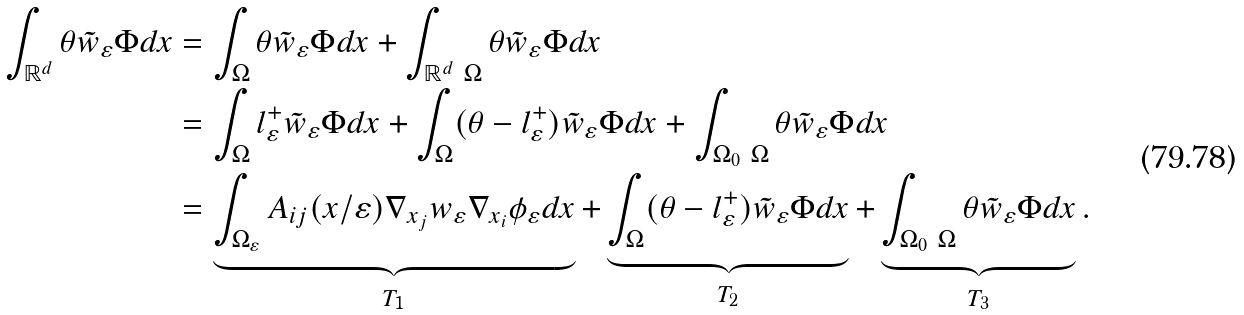Convert formula to latex. <formula><loc_0><loc_0><loc_500><loc_500>\int _ { \mathbb { R } ^ { d } } \theta \tilde { w } _ { \varepsilon } \Phi d x & = \int _ { \Omega } \theta \tilde { w } _ { \varepsilon } \Phi d x + \int _ { \mathbb { R } ^ { d } \ \Omega } \theta \tilde { w } _ { \varepsilon } \Phi d x \\ & = \int _ { \Omega } l _ { \varepsilon } ^ { + } \tilde { w } _ { \varepsilon } \Phi d x + \int _ { \Omega } ( \theta - l _ { \varepsilon } ^ { + } ) \tilde { w } _ { \varepsilon } \Phi d x + \int _ { \Omega _ { 0 } \ \Omega } \theta \tilde { w } _ { \varepsilon } \Phi d x \\ & = \underbrace { \int _ { \Omega _ { \varepsilon } } A _ { i j } ( x / \varepsilon ) \nabla _ { x _ { j } } w _ { \varepsilon } \nabla _ { x _ { i } } \phi _ { \varepsilon } d x } _ { T _ { 1 } } + \underbrace { \int _ { \Omega } ( \theta - l _ { \varepsilon } ^ { + } ) \tilde { w } _ { \varepsilon } \Phi d x } _ { T _ { 2 } } + \underbrace { \int _ { \Omega _ { 0 } \ \Omega } \theta \tilde { w } _ { \varepsilon } \Phi d x } _ { T _ { 3 } } .</formula> 